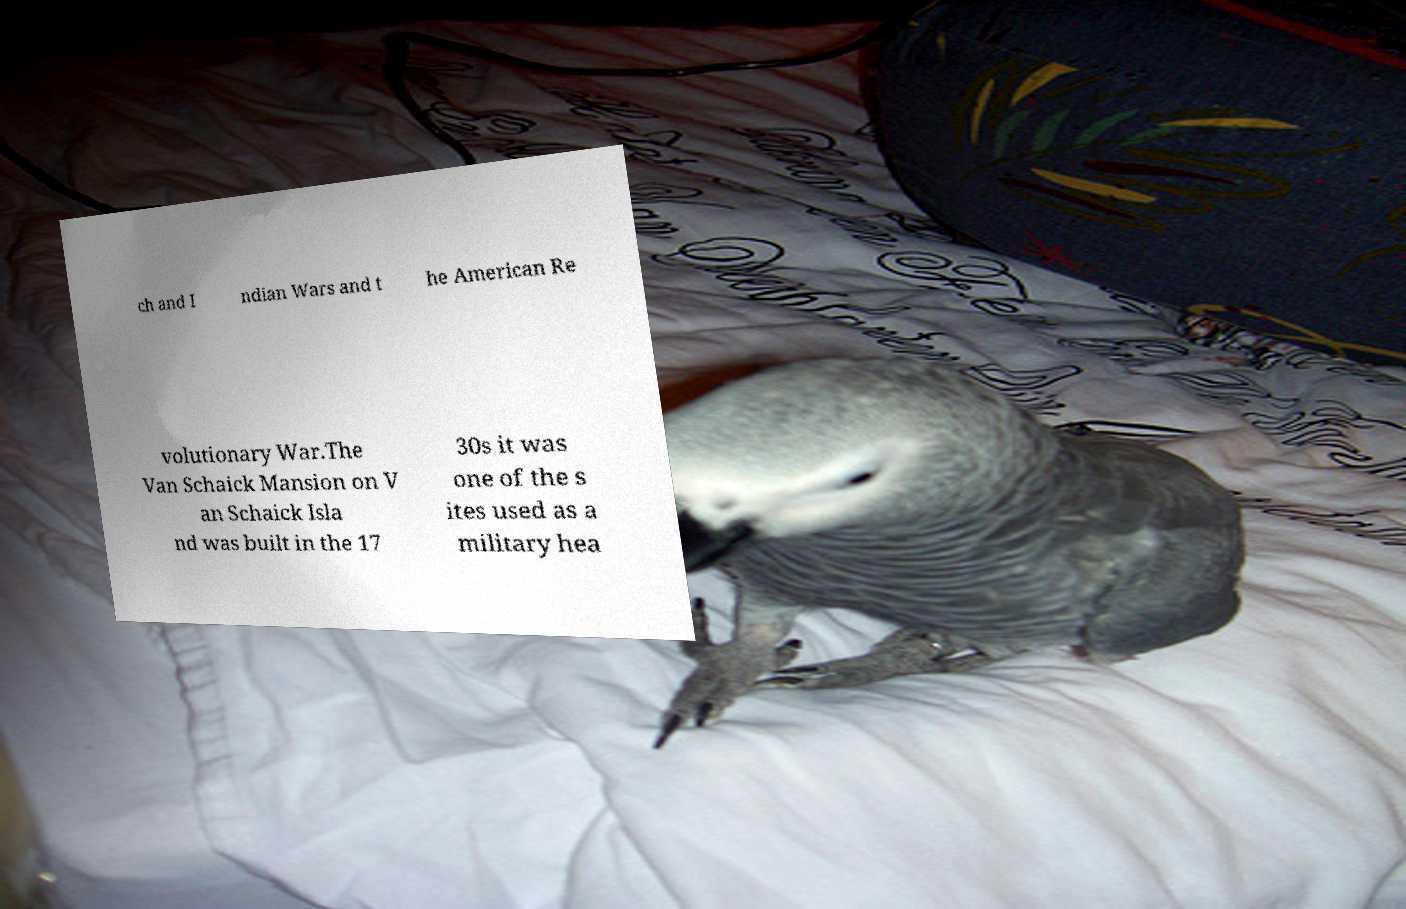Please identify and transcribe the text found in this image. ch and I ndian Wars and t he American Re volutionary War.The Van Schaick Mansion on V an Schaick Isla nd was built in the 17 30s it was one of the s ites used as a military hea 